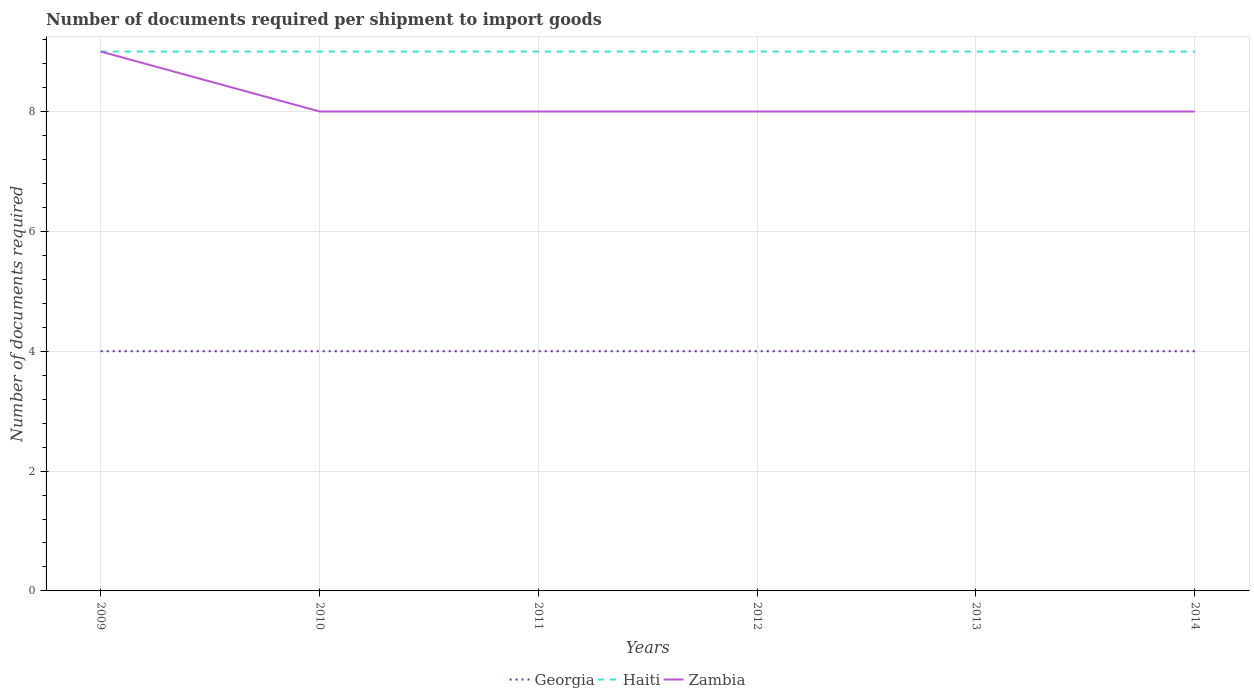Is the number of lines equal to the number of legend labels?
Offer a terse response. Yes. Across all years, what is the maximum number of documents required per shipment to import goods in Georgia?
Your response must be concise. 4. What is the total number of documents required per shipment to import goods in Zambia in the graph?
Provide a short and direct response. 0. What is the difference between the highest and the second highest number of documents required per shipment to import goods in Haiti?
Provide a succinct answer. 0. Does the graph contain any zero values?
Offer a terse response. No. Does the graph contain grids?
Your answer should be very brief. Yes. What is the title of the graph?
Offer a very short reply. Number of documents required per shipment to import goods. Does "Madagascar" appear as one of the legend labels in the graph?
Keep it short and to the point. No. What is the label or title of the Y-axis?
Offer a terse response. Number of documents required. What is the Number of documents required of Georgia in 2009?
Provide a succinct answer. 4. What is the Number of documents required of Georgia in 2010?
Your answer should be very brief. 4. What is the Number of documents required of Haiti in 2011?
Provide a short and direct response. 9. What is the Number of documents required of Georgia in 2013?
Offer a terse response. 4. What is the Number of documents required in Georgia in 2014?
Provide a succinct answer. 4. What is the Number of documents required of Haiti in 2014?
Ensure brevity in your answer.  9. What is the Number of documents required of Zambia in 2014?
Ensure brevity in your answer.  8. Across all years, what is the maximum Number of documents required of Zambia?
Provide a succinct answer. 9. Across all years, what is the minimum Number of documents required in Haiti?
Ensure brevity in your answer.  9. Across all years, what is the minimum Number of documents required in Zambia?
Provide a succinct answer. 8. What is the difference between the Number of documents required of Georgia in 2009 and that in 2010?
Make the answer very short. 0. What is the difference between the Number of documents required of Georgia in 2009 and that in 2011?
Ensure brevity in your answer.  0. What is the difference between the Number of documents required of Georgia in 2009 and that in 2012?
Make the answer very short. 0. What is the difference between the Number of documents required in Zambia in 2009 and that in 2012?
Your answer should be very brief. 1. What is the difference between the Number of documents required of Georgia in 2009 and that in 2013?
Provide a short and direct response. 0. What is the difference between the Number of documents required of Zambia in 2009 and that in 2013?
Provide a succinct answer. 1. What is the difference between the Number of documents required in Georgia in 2009 and that in 2014?
Your answer should be compact. 0. What is the difference between the Number of documents required of Haiti in 2010 and that in 2011?
Your answer should be compact. 0. What is the difference between the Number of documents required of Zambia in 2010 and that in 2011?
Give a very brief answer. 0. What is the difference between the Number of documents required in Zambia in 2010 and that in 2012?
Offer a very short reply. 0. What is the difference between the Number of documents required in Haiti in 2010 and that in 2013?
Offer a very short reply. 0. What is the difference between the Number of documents required of Zambia in 2010 and that in 2013?
Offer a terse response. 0. What is the difference between the Number of documents required of Georgia in 2010 and that in 2014?
Ensure brevity in your answer.  0. What is the difference between the Number of documents required of Haiti in 2010 and that in 2014?
Ensure brevity in your answer.  0. What is the difference between the Number of documents required of Zambia in 2010 and that in 2014?
Your answer should be compact. 0. What is the difference between the Number of documents required of Georgia in 2011 and that in 2012?
Offer a terse response. 0. What is the difference between the Number of documents required of Zambia in 2011 and that in 2012?
Keep it short and to the point. 0. What is the difference between the Number of documents required of Georgia in 2011 and that in 2013?
Offer a terse response. 0. What is the difference between the Number of documents required of Haiti in 2011 and that in 2013?
Offer a terse response. 0. What is the difference between the Number of documents required in Zambia in 2012 and that in 2013?
Provide a short and direct response. 0. What is the difference between the Number of documents required in Georgia in 2012 and that in 2014?
Ensure brevity in your answer.  0. What is the difference between the Number of documents required in Haiti in 2012 and that in 2014?
Keep it short and to the point. 0. What is the difference between the Number of documents required of Georgia in 2013 and that in 2014?
Your answer should be compact. 0. What is the difference between the Number of documents required of Georgia in 2009 and the Number of documents required of Haiti in 2011?
Provide a short and direct response. -5. What is the difference between the Number of documents required of Haiti in 2009 and the Number of documents required of Zambia in 2011?
Your answer should be compact. 1. What is the difference between the Number of documents required in Georgia in 2009 and the Number of documents required in Haiti in 2012?
Your response must be concise. -5. What is the difference between the Number of documents required of Haiti in 2009 and the Number of documents required of Zambia in 2012?
Keep it short and to the point. 1. What is the difference between the Number of documents required of Georgia in 2009 and the Number of documents required of Haiti in 2014?
Offer a terse response. -5. What is the difference between the Number of documents required of Georgia in 2010 and the Number of documents required of Zambia in 2011?
Your answer should be very brief. -4. What is the difference between the Number of documents required of Georgia in 2010 and the Number of documents required of Haiti in 2012?
Your answer should be compact. -5. What is the difference between the Number of documents required in Georgia in 2010 and the Number of documents required in Zambia in 2012?
Your response must be concise. -4. What is the difference between the Number of documents required of Haiti in 2010 and the Number of documents required of Zambia in 2012?
Make the answer very short. 1. What is the difference between the Number of documents required in Georgia in 2010 and the Number of documents required in Haiti in 2014?
Your answer should be compact. -5. What is the difference between the Number of documents required of Haiti in 2010 and the Number of documents required of Zambia in 2014?
Offer a very short reply. 1. What is the difference between the Number of documents required in Georgia in 2011 and the Number of documents required in Zambia in 2012?
Give a very brief answer. -4. What is the difference between the Number of documents required in Haiti in 2011 and the Number of documents required in Zambia in 2012?
Your answer should be very brief. 1. What is the difference between the Number of documents required of Georgia in 2011 and the Number of documents required of Haiti in 2013?
Your answer should be compact. -5. What is the difference between the Number of documents required of Georgia in 2011 and the Number of documents required of Zambia in 2013?
Offer a terse response. -4. What is the difference between the Number of documents required of Haiti in 2011 and the Number of documents required of Zambia in 2013?
Provide a short and direct response. 1. What is the difference between the Number of documents required of Georgia in 2011 and the Number of documents required of Haiti in 2014?
Your answer should be compact. -5. What is the difference between the Number of documents required of Georgia in 2011 and the Number of documents required of Zambia in 2014?
Your answer should be very brief. -4. What is the difference between the Number of documents required of Haiti in 2011 and the Number of documents required of Zambia in 2014?
Make the answer very short. 1. What is the difference between the Number of documents required of Georgia in 2012 and the Number of documents required of Haiti in 2013?
Your answer should be very brief. -5. What is the difference between the Number of documents required in Georgia in 2012 and the Number of documents required in Zambia in 2013?
Make the answer very short. -4. What is the difference between the Number of documents required of Georgia in 2012 and the Number of documents required of Haiti in 2014?
Provide a short and direct response. -5. What is the difference between the Number of documents required of Haiti in 2012 and the Number of documents required of Zambia in 2014?
Ensure brevity in your answer.  1. What is the difference between the Number of documents required of Georgia in 2013 and the Number of documents required of Haiti in 2014?
Offer a terse response. -5. What is the difference between the Number of documents required of Haiti in 2013 and the Number of documents required of Zambia in 2014?
Your response must be concise. 1. What is the average Number of documents required of Zambia per year?
Provide a short and direct response. 8.17. In the year 2009, what is the difference between the Number of documents required in Georgia and Number of documents required in Haiti?
Provide a short and direct response. -5. In the year 2009, what is the difference between the Number of documents required of Haiti and Number of documents required of Zambia?
Ensure brevity in your answer.  0. In the year 2010, what is the difference between the Number of documents required of Georgia and Number of documents required of Zambia?
Offer a very short reply. -4. In the year 2010, what is the difference between the Number of documents required in Haiti and Number of documents required in Zambia?
Your answer should be compact. 1. In the year 2011, what is the difference between the Number of documents required in Georgia and Number of documents required in Haiti?
Ensure brevity in your answer.  -5. In the year 2011, what is the difference between the Number of documents required of Haiti and Number of documents required of Zambia?
Offer a very short reply. 1. In the year 2012, what is the difference between the Number of documents required of Georgia and Number of documents required of Haiti?
Ensure brevity in your answer.  -5. In the year 2012, what is the difference between the Number of documents required of Georgia and Number of documents required of Zambia?
Keep it short and to the point. -4. In the year 2013, what is the difference between the Number of documents required in Georgia and Number of documents required in Haiti?
Provide a short and direct response. -5. In the year 2014, what is the difference between the Number of documents required of Georgia and Number of documents required of Haiti?
Provide a succinct answer. -5. What is the ratio of the Number of documents required of Georgia in 2009 to that in 2010?
Your answer should be very brief. 1. What is the ratio of the Number of documents required in Georgia in 2009 to that in 2011?
Your answer should be very brief. 1. What is the ratio of the Number of documents required of Haiti in 2009 to that in 2011?
Provide a succinct answer. 1. What is the ratio of the Number of documents required of Zambia in 2009 to that in 2011?
Make the answer very short. 1.12. What is the ratio of the Number of documents required of Haiti in 2009 to that in 2012?
Your response must be concise. 1. What is the ratio of the Number of documents required of Zambia in 2009 to that in 2012?
Make the answer very short. 1.12. What is the ratio of the Number of documents required in Georgia in 2009 to that in 2013?
Keep it short and to the point. 1. What is the ratio of the Number of documents required of Zambia in 2009 to that in 2013?
Your answer should be very brief. 1.12. What is the ratio of the Number of documents required in Haiti in 2010 to that in 2011?
Provide a succinct answer. 1. What is the ratio of the Number of documents required of Georgia in 2010 to that in 2012?
Offer a terse response. 1. What is the ratio of the Number of documents required in Zambia in 2010 to that in 2012?
Offer a very short reply. 1. What is the ratio of the Number of documents required in Georgia in 2010 to that in 2013?
Give a very brief answer. 1. What is the ratio of the Number of documents required of Haiti in 2010 to that in 2013?
Ensure brevity in your answer.  1. What is the ratio of the Number of documents required in Haiti in 2010 to that in 2014?
Your response must be concise. 1. What is the ratio of the Number of documents required of Zambia in 2010 to that in 2014?
Make the answer very short. 1. What is the ratio of the Number of documents required in Georgia in 2011 to that in 2012?
Your answer should be very brief. 1. What is the ratio of the Number of documents required of Haiti in 2011 to that in 2012?
Offer a very short reply. 1. What is the ratio of the Number of documents required of Zambia in 2011 to that in 2012?
Your answer should be compact. 1. What is the ratio of the Number of documents required in Georgia in 2011 to that in 2013?
Your response must be concise. 1. What is the ratio of the Number of documents required in Haiti in 2011 to that in 2013?
Give a very brief answer. 1. What is the ratio of the Number of documents required of Haiti in 2011 to that in 2014?
Your answer should be compact. 1. What is the ratio of the Number of documents required in Haiti in 2012 to that in 2013?
Provide a short and direct response. 1. What is the ratio of the Number of documents required in Haiti in 2012 to that in 2014?
Ensure brevity in your answer.  1. What is the ratio of the Number of documents required in Haiti in 2013 to that in 2014?
Make the answer very short. 1. What is the difference between the highest and the second highest Number of documents required of Georgia?
Your response must be concise. 0. What is the difference between the highest and the second highest Number of documents required in Haiti?
Your response must be concise. 0. What is the difference between the highest and the second highest Number of documents required in Zambia?
Your answer should be compact. 1. What is the difference between the highest and the lowest Number of documents required of Georgia?
Provide a succinct answer. 0. What is the difference between the highest and the lowest Number of documents required in Haiti?
Give a very brief answer. 0. What is the difference between the highest and the lowest Number of documents required in Zambia?
Ensure brevity in your answer.  1. 